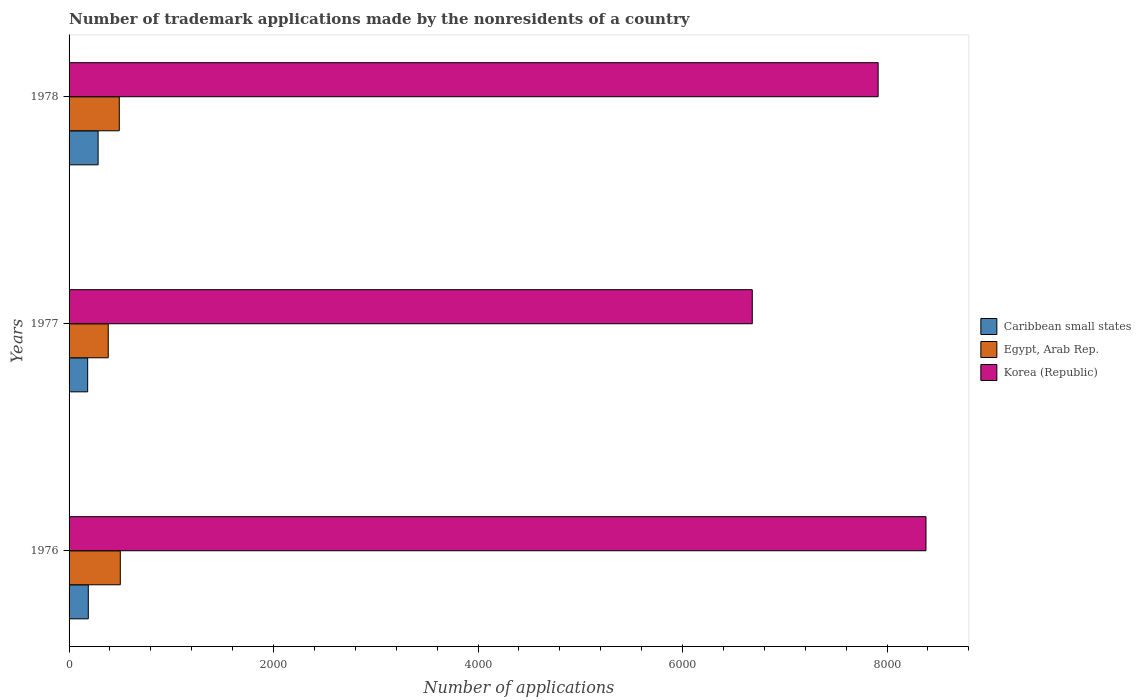How many different coloured bars are there?
Your answer should be very brief. 3. How many groups of bars are there?
Give a very brief answer. 3. Are the number of bars per tick equal to the number of legend labels?
Provide a succinct answer. Yes. Are the number of bars on each tick of the Y-axis equal?
Give a very brief answer. Yes. How many bars are there on the 2nd tick from the bottom?
Provide a succinct answer. 3. What is the label of the 3rd group of bars from the top?
Your answer should be compact. 1976. In how many cases, is the number of bars for a given year not equal to the number of legend labels?
Make the answer very short. 0. What is the number of trademark applications made by the nonresidents in Egypt, Arab Rep. in 1978?
Provide a succinct answer. 491. Across all years, what is the maximum number of trademark applications made by the nonresidents in Caribbean small states?
Keep it short and to the point. 284. Across all years, what is the minimum number of trademark applications made by the nonresidents in Korea (Republic)?
Ensure brevity in your answer.  6682. In which year was the number of trademark applications made by the nonresidents in Egypt, Arab Rep. maximum?
Keep it short and to the point. 1976. In which year was the number of trademark applications made by the nonresidents in Korea (Republic) minimum?
Your answer should be compact. 1977. What is the total number of trademark applications made by the nonresidents in Caribbean small states in the graph?
Provide a short and direct response. 654. What is the difference between the number of trademark applications made by the nonresidents in Egypt, Arab Rep. in 1977 and that in 1978?
Your answer should be compact. -108. What is the difference between the number of trademark applications made by the nonresidents in Korea (Republic) in 1978 and the number of trademark applications made by the nonresidents in Caribbean small states in 1977?
Provide a succinct answer. 7731. What is the average number of trademark applications made by the nonresidents in Egypt, Arab Rep. per year?
Your answer should be very brief. 458.33. In the year 1977, what is the difference between the number of trademark applications made by the nonresidents in Korea (Republic) and number of trademark applications made by the nonresidents in Egypt, Arab Rep.?
Keep it short and to the point. 6299. In how many years, is the number of trademark applications made by the nonresidents in Korea (Republic) greater than 3600 ?
Provide a succinct answer. 3. What is the ratio of the number of trademark applications made by the nonresidents in Caribbean small states in 1976 to that in 1977?
Provide a succinct answer. 1.03. Is the difference between the number of trademark applications made by the nonresidents in Korea (Republic) in 1976 and 1977 greater than the difference between the number of trademark applications made by the nonresidents in Egypt, Arab Rep. in 1976 and 1977?
Your response must be concise. Yes. What is the difference between the highest and the second highest number of trademark applications made by the nonresidents in Korea (Republic)?
Your response must be concise. 468. What is the difference between the highest and the lowest number of trademark applications made by the nonresidents in Caribbean small states?
Provide a succinct answer. 102. In how many years, is the number of trademark applications made by the nonresidents in Korea (Republic) greater than the average number of trademark applications made by the nonresidents in Korea (Republic) taken over all years?
Your answer should be very brief. 2. Is the sum of the number of trademark applications made by the nonresidents in Caribbean small states in 1976 and 1978 greater than the maximum number of trademark applications made by the nonresidents in Korea (Republic) across all years?
Provide a succinct answer. No. What does the 2nd bar from the top in 1976 represents?
Keep it short and to the point. Egypt, Arab Rep. What does the 2nd bar from the bottom in 1978 represents?
Ensure brevity in your answer.  Egypt, Arab Rep. Is it the case that in every year, the sum of the number of trademark applications made by the nonresidents in Caribbean small states and number of trademark applications made by the nonresidents in Korea (Republic) is greater than the number of trademark applications made by the nonresidents in Egypt, Arab Rep.?
Ensure brevity in your answer.  Yes. How many bars are there?
Offer a very short reply. 9. How many years are there in the graph?
Make the answer very short. 3. What is the difference between two consecutive major ticks on the X-axis?
Your answer should be compact. 2000. Does the graph contain any zero values?
Your answer should be compact. No. Does the graph contain grids?
Offer a very short reply. No. How are the legend labels stacked?
Offer a terse response. Vertical. What is the title of the graph?
Provide a short and direct response. Number of trademark applications made by the nonresidents of a country. What is the label or title of the X-axis?
Your answer should be very brief. Number of applications. What is the Number of applications in Caribbean small states in 1976?
Provide a succinct answer. 188. What is the Number of applications of Egypt, Arab Rep. in 1976?
Offer a very short reply. 501. What is the Number of applications in Korea (Republic) in 1976?
Your answer should be compact. 8381. What is the Number of applications in Caribbean small states in 1977?
Offer a terse response. 182. What is the Number of applications of Egypt, Arab Rep. in 1977?
Make the answer very short. 383. What is the Number of applications in Korea (Republic) in 1977?
Offer a terse response. 6682. What is the Number of applications in Caribbean small states in 1978?
Ensure brevity in your answer.  284. What is the Number of applications in Egypt, Arab Rep. in 1978?
Offer a very short reply. 491. What is the Number of applications of Korea (Republic) in 1978?
Give a very brief answer. 7913. Across all years, what is the maximum Number of applications of Caribbean small states?
Offer a very short reply. 284. Across all years, what is the maximum Number of applications in Egypt, Arab Rep.?
Your answer should be very brief. 501. Across all years, what is the maximum Number of applications in Korea (Republic)?
Ensure brevity in your answer.  8381. Across all years, what is the minimum Number of applications of Caribbean small states?
Ensure brevity in your answer.  182. Across all years, what is the minimum Number of applications in Egypt, Arab Rep.?
Offer a very short reply. 383. Across all years, what is the minimum Number of applications in Korea (Republic)?
Your response must be concise. 6682. What is the total Number of applications in Caribbean small states in the graph?
Your response must be concise. 654. What is the total Number of applications in Egypt, Arab Rep. in the graph?
Provide a succinct answer. 1375. What is the total Number of applications in Korea (Republic) in the graph?
Ensure brevity in your answer.  2.30e+04. What is the difference between the Number of applications in Egypt, Arab Rep. in 1976 and that in 1977?
Your answer should be very brief. 118. What is the difference between the Number of applications in Korea (Republic) in 1976 and that in 1977?
Make the answer very short. 1699. What is the difference between the Number of applications in Caribbean small states in 1976 and that in 1978?
Offer a terse response. -96. What is the difference between the Number of applications in Egypt, Arab Rep. in 1976 and that in 1978?
Offer a terse response. 10. What is the difference between the Number of applications in Korea (Republic) in 1976 and that in 1978?
Ensure brevity in your answer.  468. What is the difference between the Number of applications of Caribbean small states in 1977 and that in 1978?
Ensure brevity in your answer.  -102. What is the difference between the Number of applications of Egypt, Arab Rep. in 1977 and that in 1978?
Provide a succinct answer. -108. What is the difference between the Number of applications of Korea (Republic) in 1977 and that in 1978?
Offer a terse response. -1231. What is the difference between the Number of applications of Caribbean small states in 1976 and the Number of applications of Egypt, Arab Rep. in 1977?
Your answer should be very brief. -195. What is the difference between the Number of applications of Caribbean small states in 1976 and the Number of applications of Korea (Republic) in 1977?
Offer a terse response. -6494. What is the difference between the Number of applications in Egypt, Arab Rep. in 1976 and the Number of applications in Korea (Republic) in 1977?
Your answer should be very brief. -6181. What is the difference between the Number of applications in Caribbean small states in 1976 and the Number of applications in Egypt, Arab Rep. in 1978?
Give a very brief answer. -303. What is the difference between the Number of applications in Caribbean small states in 1976 and the Number of applications in Korea (Republic) in 1978?
Your response must be concise. -7725. What is the difference between the Number of applications of Egypt, Arab Rep. in 1976 and the Number of applications of Korea (Republic) in 1978?
Your answer should be compact. -7412. What is the difference between the Number of applications in Caribbean small states in 1977 and the Number of applications in Egypt, Arab Rep. in 1978?
Ensure brevity in your answer.  -309. What is the difference between the Number of applications of Caribbean small states in 1977 and the Number of applications of Korea (Republic) in 1978?
Give a very brief answer. -7731. What is the difference between the Number of applications in Egypt, Arab Rep. in 1977 and the Number of applications in Korea (Republic) in 1978?
Ensure brevity in your answer.  -7530. What is the average Number of applications of Caribbean small states per year?
Your response must be concise. 218. What is the average Number of applications in Egypt, Arab Rep. per year?
Make the answer very short. 458.33. What is the average Number of applications in Korea (Republic) per year?
Give a very brief answer. 7658.67. In the year 1976, what is the difference between the Number of applications in Caribbean small states and Number of applications in Egypt, Arab Rep.?
Provide a short and direct response. -313. In the year 1976, what is the difference between the Number of applications in Caribbean small states and Number of applications in Korea (Republic)?
Provide a short and direct response. -8193. In the year 1976, what is the difference between the Number of applications of Egypt, Arab Rep. and Number of applications of Korea (Republic)?
Provide a short and direct response. -7880. In the year 1977, what is the difference between the Number of applications of Caribbean small states and Number of applications of Egypt, Arab Rep.?
Give a very brief answer. -201. In the year 1977, what is the difference between the Number of applications of Caribbean small states and Number of applications of Korea (Republic)?
Offer a very short reply. -6500. In the year 1977, what is the difference between the Number of applications in Egypt, Arab Rep. and Number of applications in Korea (Republic)?
Your response must be concise. -6299. In the year 1978, what is the difference between the Number of applications in Caribbean small states and Number of applications in Egypt, Arab Rep.?
Keep it short and to the point. -207. In the year 1978, what is the difference between the Number of applications of Caribbean small states and Number of applications of Korea (Republic)?
Ensure brevity in your answer.  -7629. In the year 1978, what is the difference between the Number of applications of Egypt, Arab Rep. and Number of applications of Korea (Republic)?
Ensure brevity in your answer.  -7422. What is the ratio of the Number of applications of Caribbean small states in 1976 to that in 1977?
Your response must be concise. 1.03. What is the ratio of the Number of applications in Egypt, Arab Rep. in 1976 to that in 1977?
Provide a short and direct response. 1.31. What is the ratio of the Number of applications of Korea (Republic) in 1976 to that in 1977?
Your response must be concise. 1.25. What is the ratio of the Number of applications of Caribbean small states in 1976 to that in 1978?
Keep it short and to the point. 0.66. What is the ratio of the Number of applications of Egypt, Arab Rep. in 1976 to that in 1978?
Your answer should be very brief. 1.02. What is the ratio of the Number of applications in Korea (Republic) in 1976 to that in 1978?
Provide a succinct answer. 1.06. What is the ratio of the Number of applications in Caribbean small states in 1977 to that in 1978?
Make the answer very short. 0.64. What is the ratio of the Number of applications in Egypt, Arab Rep. in 1977 to that in 1978?
Provide a succinct answer. 0.78. What is the ratio of the Number of applications in Korea (Republic) in 1977 to that in 1978?
Offer a very short reply. 0.84. What is the difference between the highest and the second highest Number of applications of Caribbean small states?
Make the answer very short. 96. What is the difference between the highest and the second highest Number of applications in Egypt, Arab Rep.?
Provide a short and direct response. 10. What is the difference between the highest and the second highest Number of applications of Korea (Republic)?
Your answer should be compact. 468. What is the difference between the highest and the lowest Number of applications of Caribbean small states?
Offer a very short reply. 102. What is the difference between the highest and the lowest Number of applications of Egypt, Arab Rep.?
Offer a very short reply. 118. What is the difference between the highest and the lowest Number of applications of Korea (Republic)?
Your answer should be very brief. 1699. 